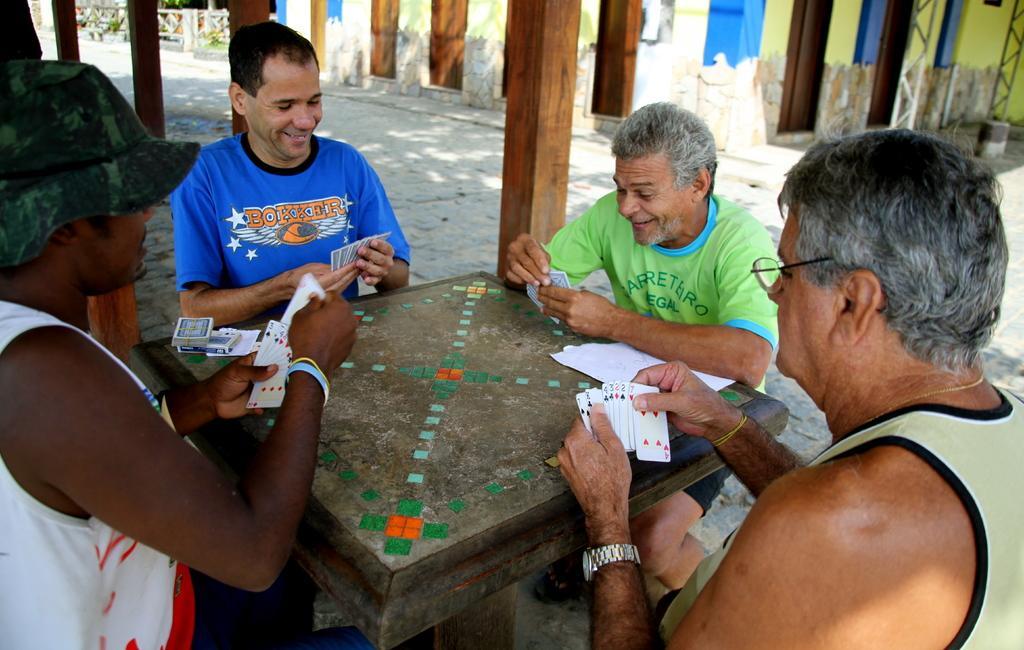Describe this image in one or two sentences. In this image there are four men sitting around a table and playing cards. The person towards the left he is wearing white t shirt and green hat beside him there is another person wearing blue T shirt. The person towards the right he is wearing a cream top and spectacles behind him there is another person wearing green T shirt. In the background there are houses and plants. 